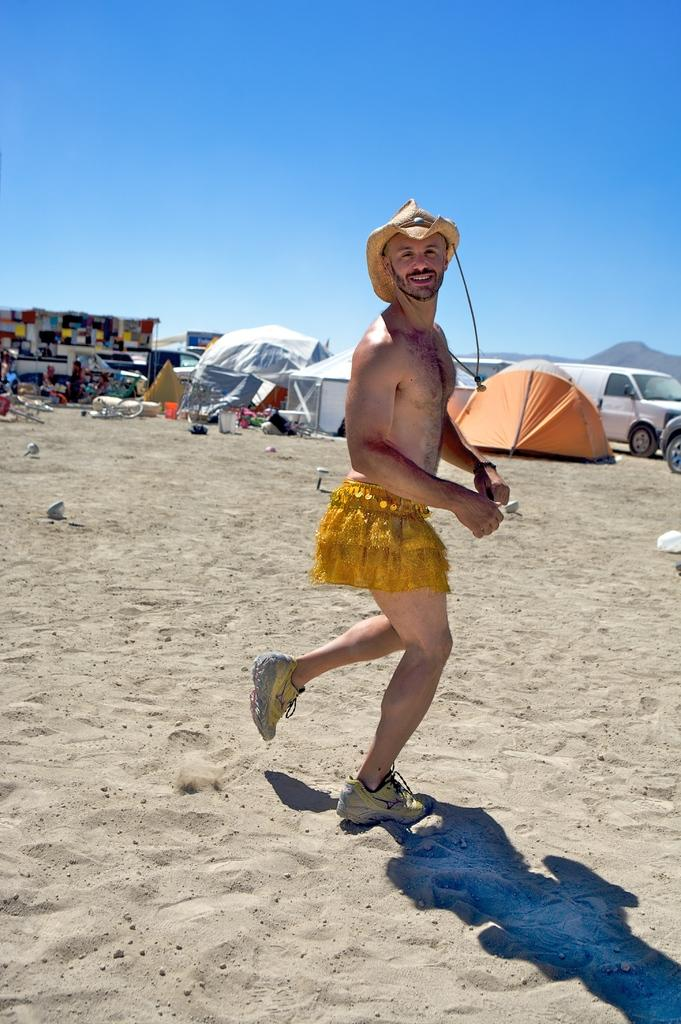What is the person in the image standing on? The person is standing on the sand. What type of temporary shelters can be seen in the image? There are tents in the image. What mode of transportation is present in the image? There are vehicles in the image. What type of structure can be seen selling goods or services in the image? There is a stall in the image. What type of natural landform is visible in the image? There are hills in the image. What is visible in the background of the image? The sky is visible in the background of the image. What type of jelly can be seen on the person's neck in the image? There is no jelly or any reference to a person's neck in the image. 